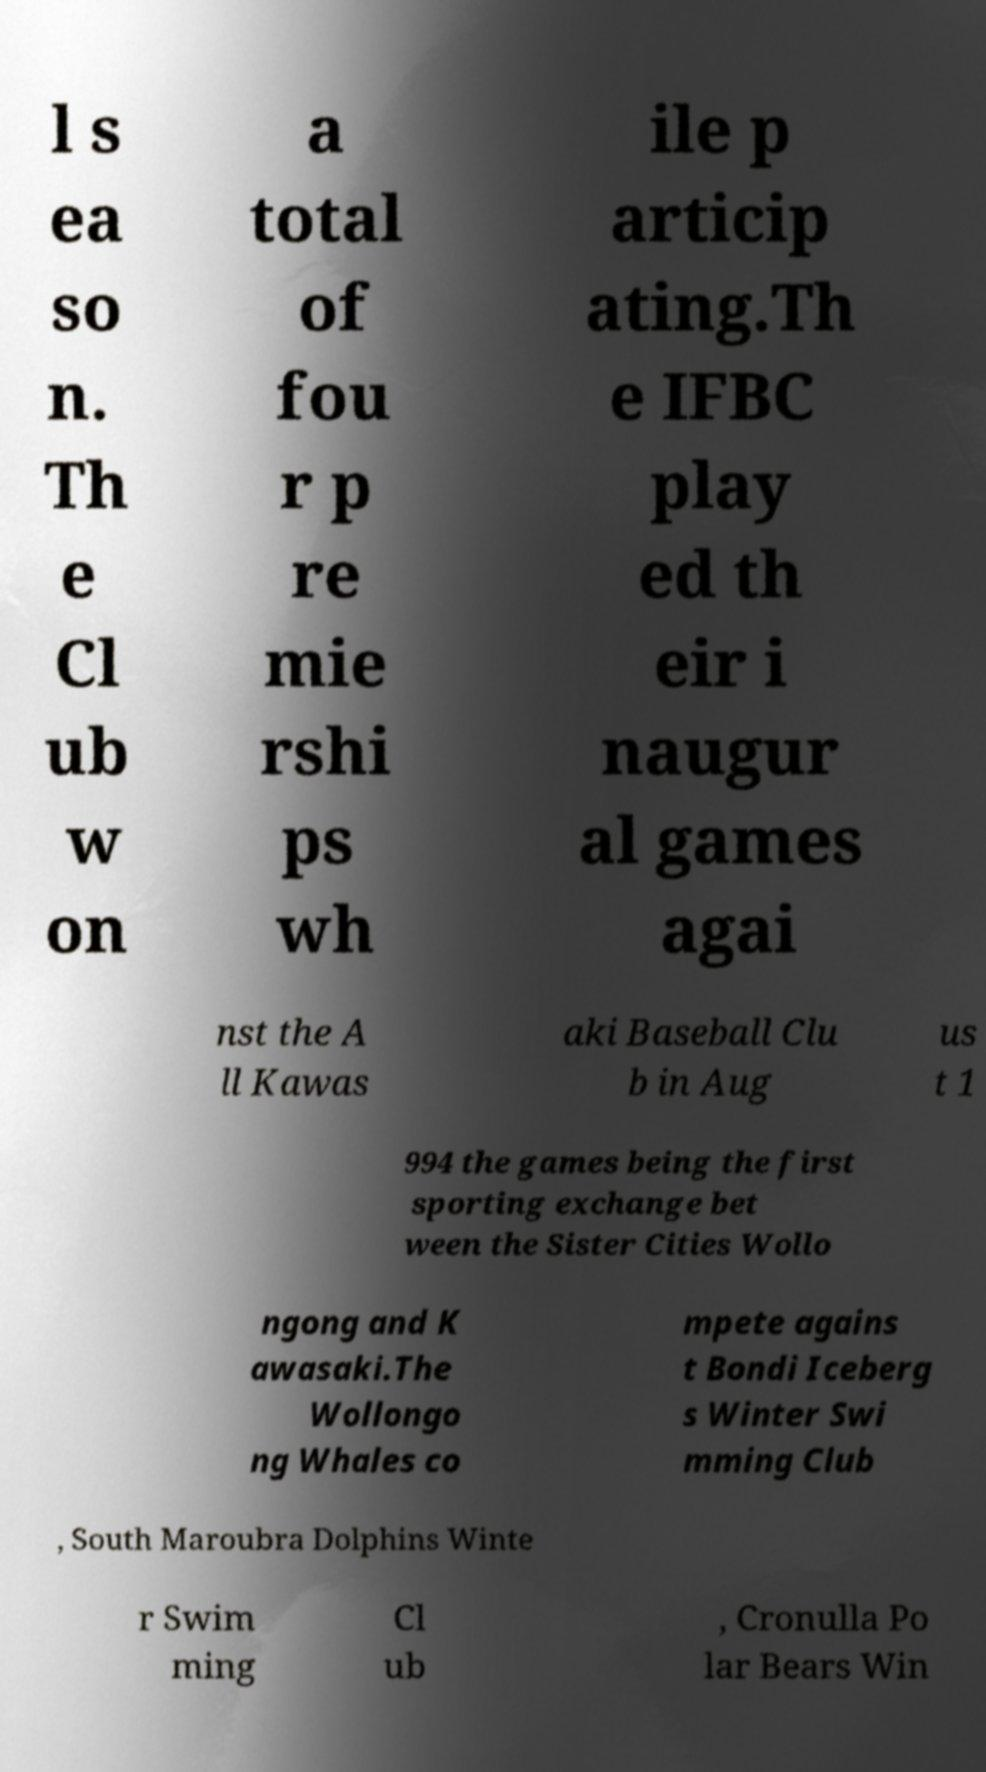Please identify and transcribe the text found in this image. l s ea so n. Th e Cl ub w on a total of fou r p re mie rshi ps wh ile p articip ating.Th e IFBC play ed th eir i naugur al games agai nst the A ll Kawas aki Baseball Clu b in Aug us t 1 994 the games being the first sporting exchange bet ween the Sister Cities Wollo ngong and K awasaki.The Wollongo ng Whales co mpete agains t Bondi Iceberg s Winter Swi mming Club , South Maroubra Dolphins Winte r Swim ming Cl ub , Cronulla Po lar Bears Win 